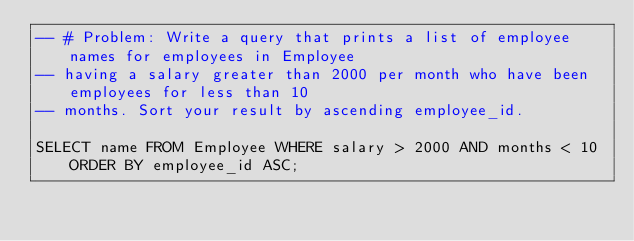Convert code to text. <code><loc_0><loc_0><loc_500><loc_500><_SQL_>-- # Problem: Write a query that prints a list of employee names for employees in Employee
-- having a salary greater than 2000 per month who have been employees for less than 10 
-- months. Sort your result by ascending employee_id.

SELECT name FROM Employee WHERE salary > 2000 AND months < 10 ORDER BY employee_id ASC;</code> 